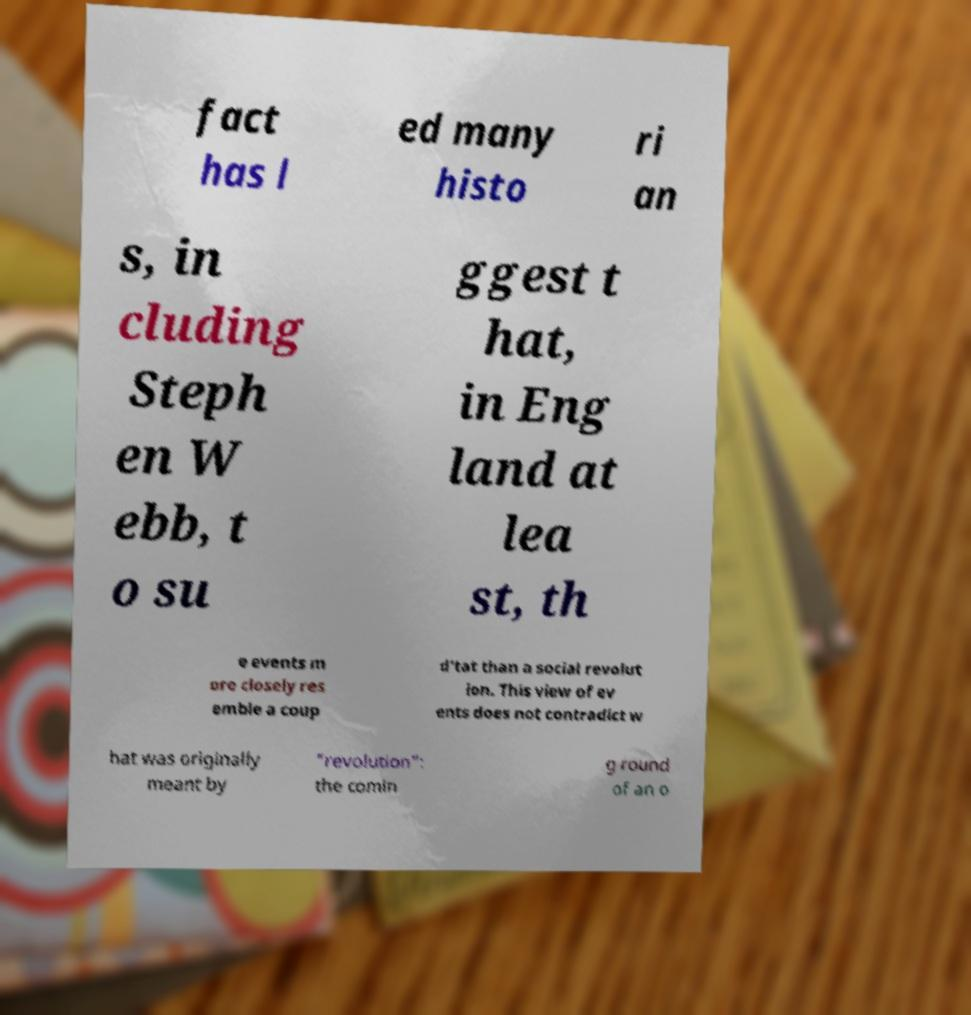What messages or text are displayed in this image? I need them in a readable, typed format. fact has l ed many histo ri an s, in cluding Steph en W ebb, t o su ggest t hat, in Eng land at lea st, th e events m ore closely res emble a coup d'tat than a social revolut ion. This view of ev ents does not contradict w hat was originally meant by "revolution": the comin g round of an o 